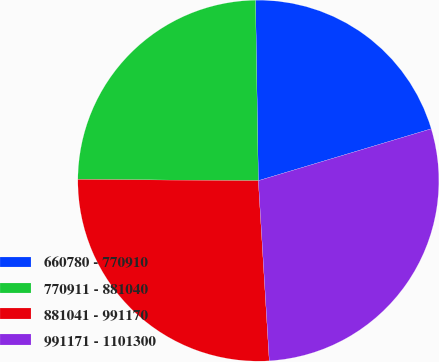<chart> <loc_0><loc_0><loc_500><loc_500><pie_chart><fcel>660780 - 770910<fcel>770911 - 881040<fcel>881041 - 991170<fcel>991171 - 1101300<nl><fcel>20.61%<fcel>24.64%<fcel>26.07%<fcel>28.67%<nl></chart> 